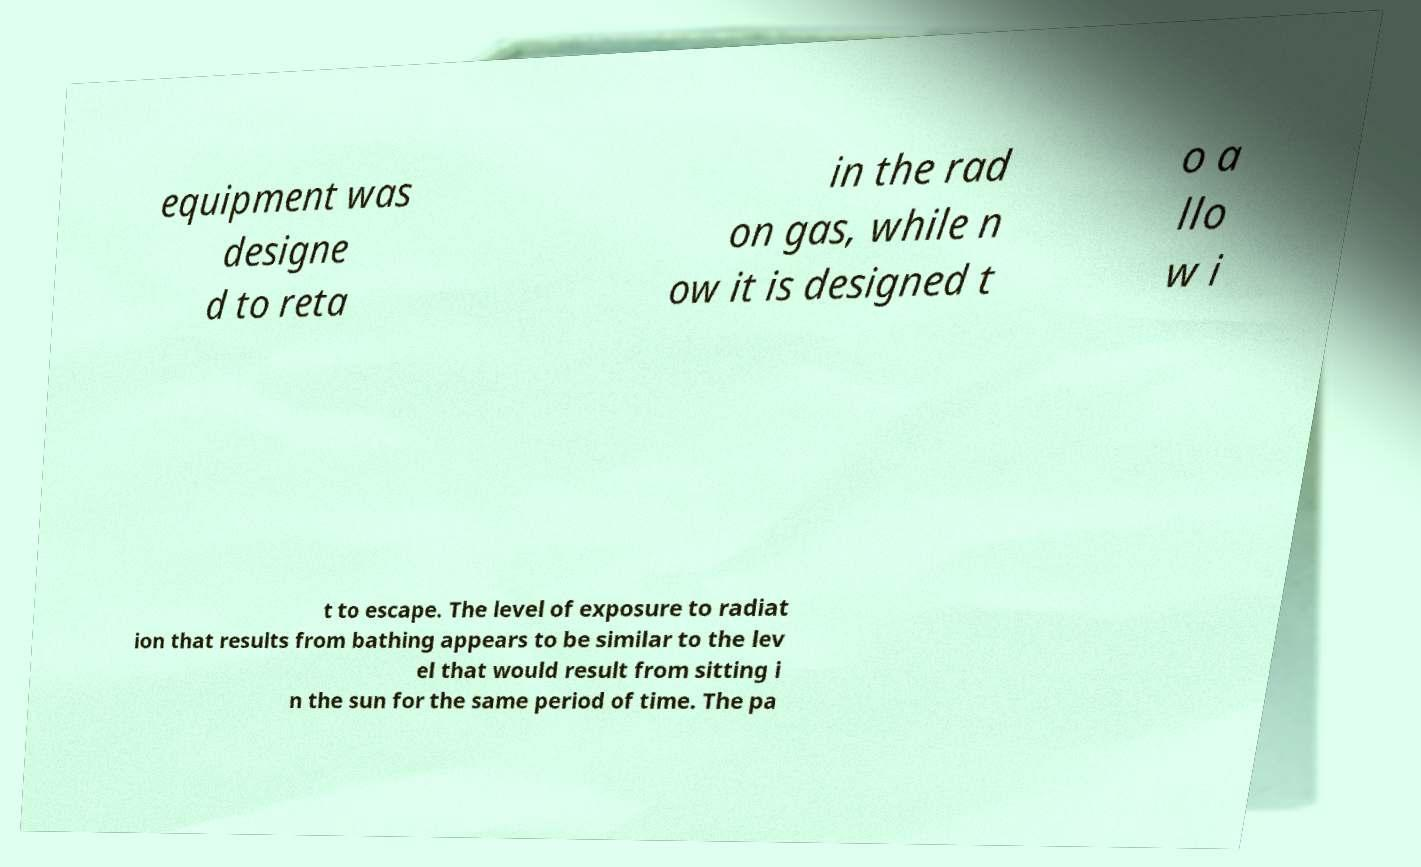What messages or text are displayed in this image? I need them in a readable, typed format. equipment was designe d to reta in the rad on gas, while n ow it is designed t o a llo w i t to escape. The level of exposure to radiat ion that results from bathing appears to be similar to the lev el that would result from sitting i n the sun for the same period of time. The pa 